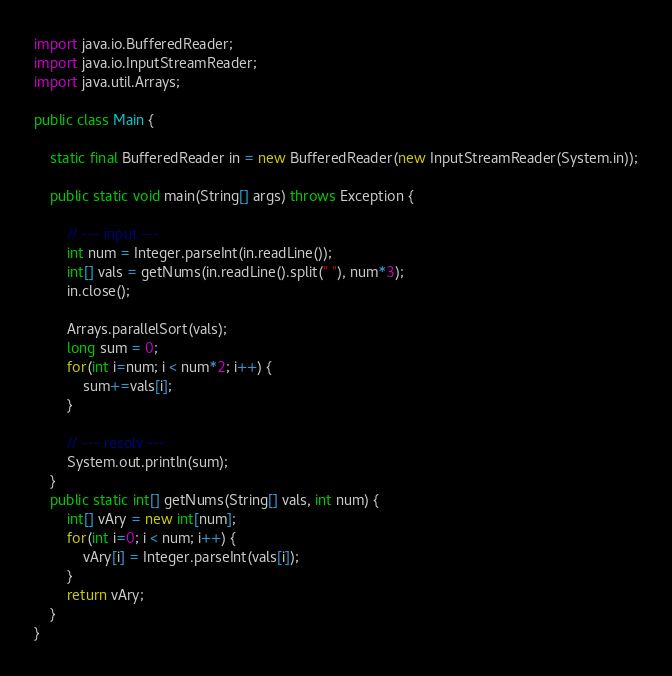<code> <loc_0><loc_0><loc_500><loc_500><_Java_>import java.io.BufferedReader;
import java.io.InputStreamReader;
import java.util.Arrays;

public class Main {

	static final BufferedReader in = new BufferedReader(new InputStreamReader(System.in));

	public static void main(String[] args) throws Exception {

		// --- input ---
		int num = Integer.parseInt(in.readLine());
		int[] vals = getNums(in.readLine().split(" "), num*3);
		in.close();

		Arrays.parallelSort(vals);
		long sum = 0;
		for(int i=num; i < num*2; i++) {
			sum+=vals[i];
		}

		// --- resolv ---
		System.out.println(sum);
	}
	public static int[] getNums(String[] vals, int num) {
		int[] vAry = new int[num];
		for(int i=0; i < num; i++) {
			vAry[i] = Integer.parseInt(vals[i]);
		}
		return vAry;
	}
}</code> 